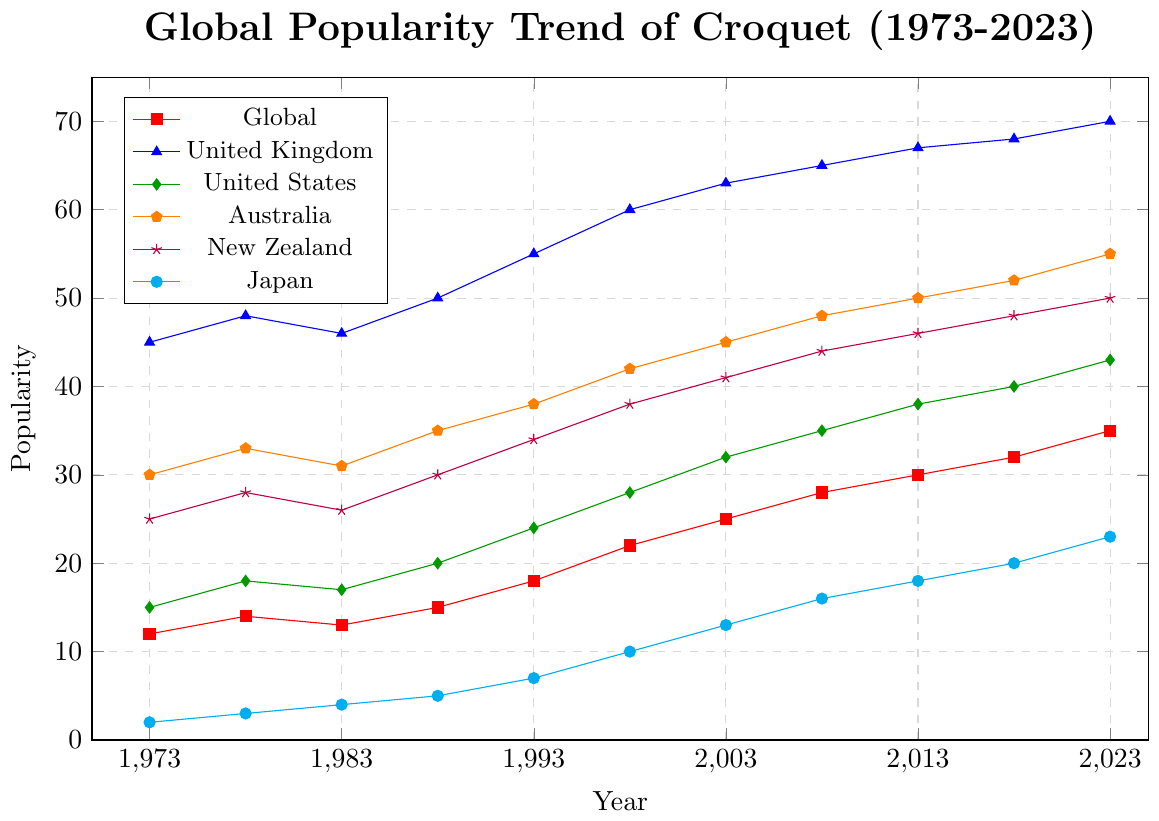What is the trend of global popularity of croquet from 1973 to 2023? The trend shows a consistent increase in the global popularity of croquet over the years. Starting from 12 in 1973 and gradually rising to 35 by 2023.
Answer: Increasing Which country had the highest popularity of croquet in 2023? Looking at the 2023 data, the United Kingdom has the highest popularity with a value of 70.
Answer: United Kingdom How did the popularity of croquet in the United States change between 1973 and 2023? In 1973, the popularity in the United States was 15. It increased over the years to reach 43 in 2023.
Answer: Increased from 15 to 43 Among Australia and New Zealand, which country had a higher increase in croquet popularity from 1973 to 2023? In 1973, Australia had a popularity of 30 and New Zealand had 25; in 2023, Australia had 55 and New Zealand had 50. The increase for Australia is 55 - 30 = 25, and for New Zealand is 50 - 25 = 25. Both countries had the same increase of 25.
Answer: Both the same How does the popularity of croquet in Japan in 1988 compare to 2023? In 1988, the popularity in Japan was 5, and in 2023, it was 23. The popularity in Japan increased from 5 to 23.
Answer: Increased from 5 to 23 Which region had the highest increase in croquet popularity from 1973 to 2023? The United Kingdom started at 45 in 1973 and reached 70 in 2023. The increase is 70 - 45 = 25. The United States increased from 15 to 43, resulting in an increase of 28. Australia increased from 30 to 55, an increase of 25. New Zealand increased from 25 to 50, an increase of 25. Japan increased from 2 to 23, an increase of 21. The United States had the highest increase of 28.
Answer: United States In which year did croquet reach a popularity of 50 in Australia? Looking at Australia's trendline, croquet reached a popularity of 50 in 2013.
Answer: 2013 What was the global popularity of croquet in 1998? In 1998, the global popularity of croquet was 22 according to the global trend line.
Answer: 22 Compare the trends of croquet popularity in the United Kingdom and New Zealand. The United Kingdom consistently has a higher popularity compared to New Zealand throughout the years. The UK increases from 45 in 1973 to 70 in 2023, while New Zealand goes from 25 to 50 in the same period. Both trends show an increasing pattern.
Answer: United Kingdom higher and increasing What was the combined popularity of croquet in Australia and Japan in 2003? In 2003, Australia's popularity was 45 and Japan's was 13. Adding these together gives 45 + 13 = 58.
Answer: 58 How does the trend in New Zealand compare to the global trend from 1973 to 2023? Both trends show an increase over the years. New Zealand starts at 25 and reaches 50, while the global trend starts at 12 and reaches 35. New Zealand has a steeper increase than the global trend.
Answer: New Zealand increased more steeply 